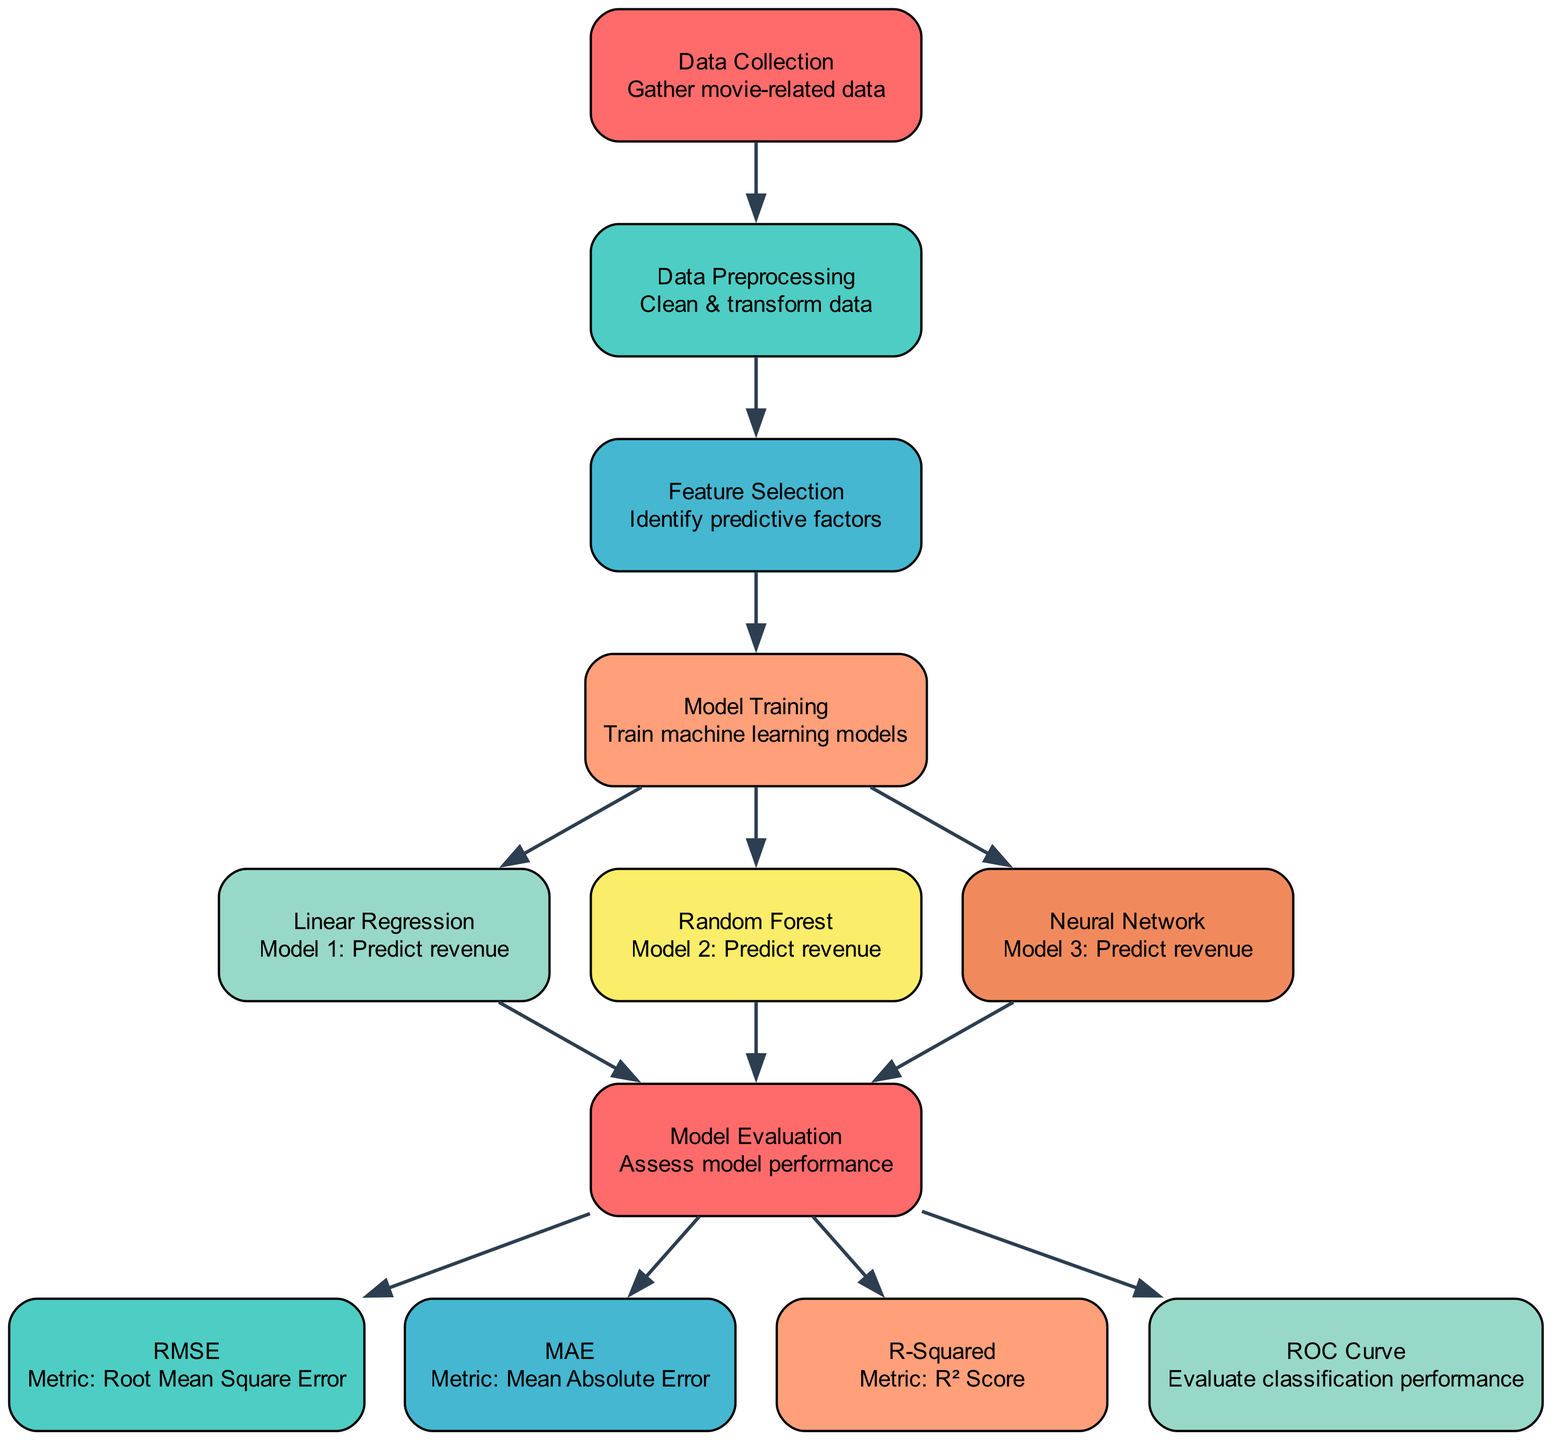What is the first step in the process? The first step is indicated by the node labeled "Data Collection." This node represents the initial action of gathering movie-related data, which is the starting point of the diagram.
Answer: Data Collection How many machine learning models are trained? There are three distinct machine learning models listed in the diagram: Linear Regression, Random Forest, and Neural Network. Each of these models is trained after the "Model Training" node.
Answer: Three Which evaluation metric corresponds to the acronym "RMSE"? The term RMSE stands for Root Mean Square Error, which is specified in the diagram under the RMSE node. This metric is used to assess the model's performance.
Answer: Root Mean Square Error What is the purpose of the "Model Evaluation" node? The "Model Evaluation" node serves to gather outputs from the three machine learning models to assess their performance using various evaluation metrics. It follows directly after the model training phase.
Answer: Assess model performance Which model has the potential to learn complex patterns? The Neural Network model is known for its ability to learn complex patterns in data, as indicated in the diagram. This model typically excels in scenarios with intricate relationships.
Answer: Neural Network What is the next step after "Feature Selection"? Following "Feature Selection," the next step is "Model Training," where different machine learning models are trained to make predictions based on the identified features.
Answer: Model Training Which metric is used to evaluate classification performance? The metric used to evaluate classification performance is represented by the "ROC Curve" node in the diagram. It is specifically designated for analyzing the performance of classification models.
Answer: ROC Curve How many edges connect the "Model Training" node to the models? The "Model Training" node has three outgoing edges, each connecting to one of the machine learning models: Linear Regression, Random Forest, and Neural Network.
Answer: Three What is the last step in the evaluation process? The last step in the evaluation process is the "ROC Curve," which assesses the classification performance after various evaluation metrics have been computed.
Answer: ROC Curve 